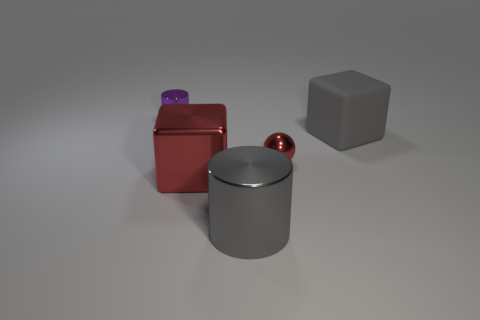Add 4 tiny blue shiny cubes. How many objects exist? 9 Subtract all cylinders. How many objects are left? 3 Subtract all purple shiny cubes. Subtract all red objects. How many objects are left? 3 Add 4 purple cylinders. How many purple cylinders are left? 5 Add 1 large blocks. How many large blocks exist? 3 Subtract 1 red cubes. How many objects are left? 4 